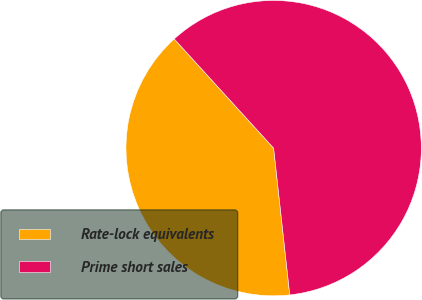Convert chart to OTSL. <chart><loc_0><loc_0><loc_500><loc_500><pie_chart><fcel>Rate-lock equivalents<fcel>Prime short sales<nl><fcel>39.99%<fcel>60.01%<nl></chart> 